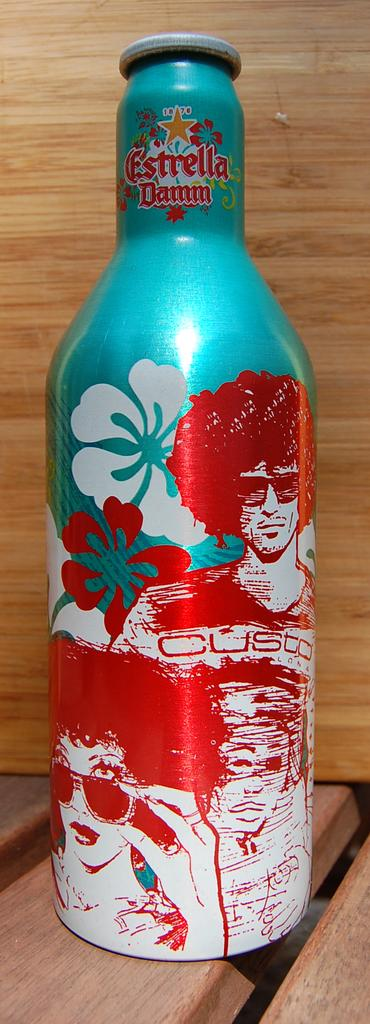<image>
Write a terse but informative summary of the picture. A decorative bottle of Estrella Damm is on a counter 